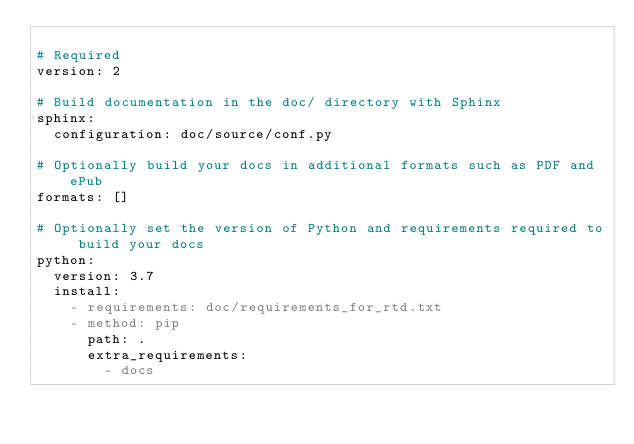Convert code to text. <code><loc_0><loc_0><loc_500><loc_500><_YAML_>
# Required
version: 2

# Build documentation in the doc/ directory with Sphinx
sphinx:
  configuration: doc/source/conf.py

# Optionally build your docs in additional formats such as PDF and ePub
formats: []

# Optionally set the version of Python and requirements required to build your docs
python:
  version: 3.7
  install:
    - requirements: doc/requirements_for_rtd.txt
    - method: pip
      path: .
      extra_requirements:
        - docs
</code> 